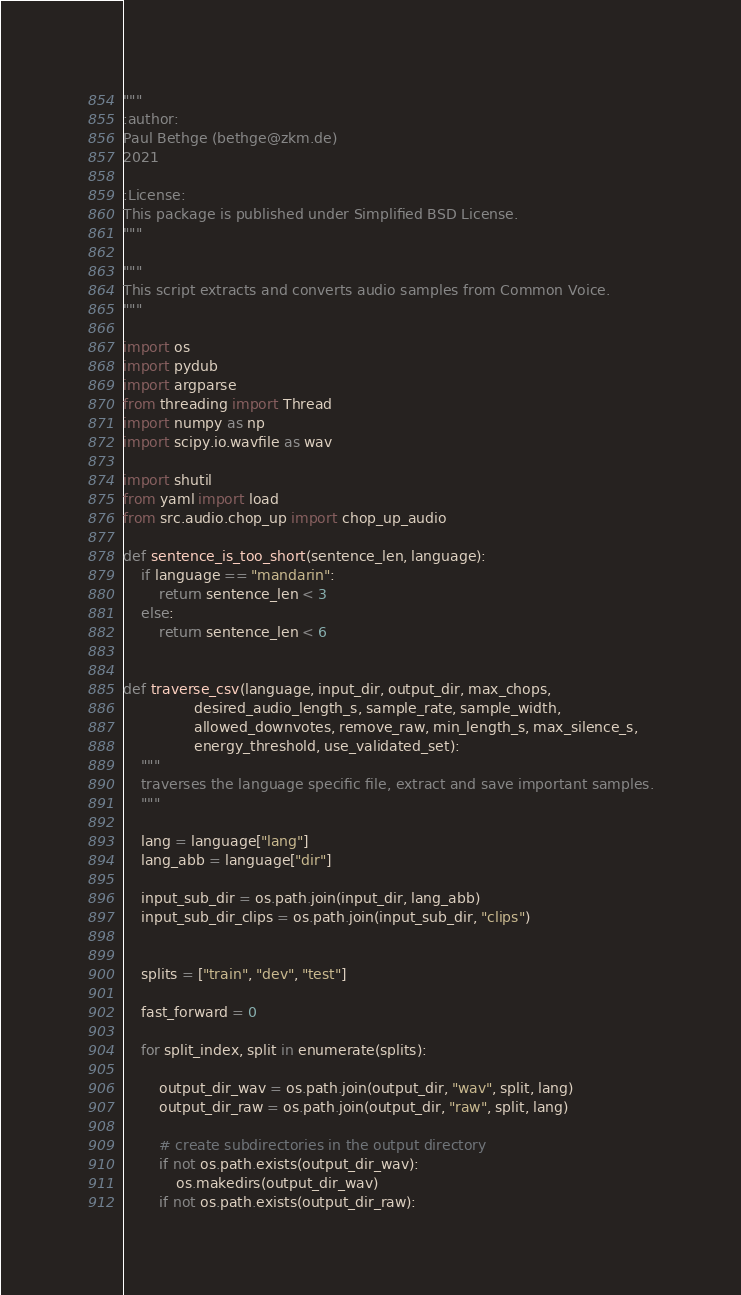Convert code to text. <code><loc_0><loc_0><loc_500><loc_500><_Python_>"""
:author:
Paul Bethge (bethge@zkm.de)
2021

:License:
This package is published under Simplified BSD License.
"""

"""
This script extracts and converts audio samples from Common Voice.
"""

import os
import pydub
import argparse
from threading import Thread
import numpy as np
import scipy.io.wavfile as wav

import shutil
from yaml import load
from src.audio.chop_up import chop_up_audio

def sentence_is_too_short(sentence_len, language):
	if language == "mandarin":
		return sentence_len < 3
	else:
		return sentence_len < 6


def traverse_csv(language, input_dir, output_dir, max_chops, 
				desired_audio_length_s, sample_rate, sample_width,
				allowed_downvotes, remove_raw, min_length_s, max_silence_s,
				energy_threshold, use_validated_set):
	"""
	traverses the language specific file, extract and save important samples.
	"""
	
	lang = language["lang"]
	lang_abb = language["dir"]

	input_sub_dir = os.path.join(input_dir, lang_abb)
	input_sub_dir_clips = os.path.join(input_sub_dir, "clips")


	splits = ["train", "dev", "test"]

	fast_forward = 0	

	for split_index, split in enumerate(splits):

		output_dir_wav = os.path.join(output_dir, "wav", split, lang)
		output_dir_raw = os.path.join(output_dir, "raw", split, lang)

		# create subdirectories in the output directory
		if not os.path.exists(output_dir_wav):
			os.makedirs(output_dir_wav)
		if not os.path.exists(output_dir_raw):</code> 